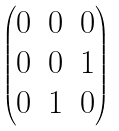Convert formula to latex. <formula><loc_0><loc_0><loc_500><loc_500>\begin{pmatrix} 0 & 0 & 0 \\ 0 & 0 & 1 \\ 0 & 1 & 0 \\ \end{pmatrix}</formula> 